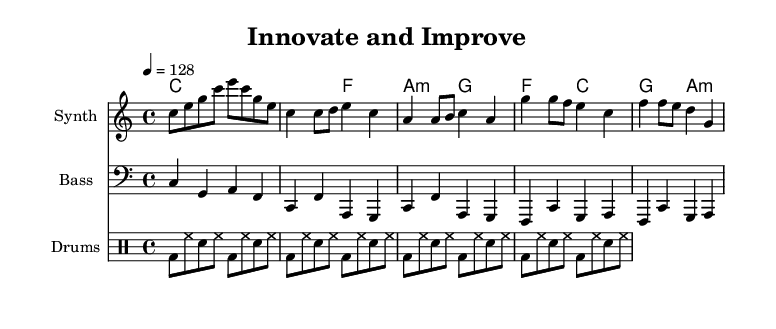What is the key signature of this music? The key signature is C major, which has no sharps or flats.
Answer: C major What is the time signature of this music? The time signature is indicated as 4/4, meaning there are four beats in a measure.
Answer: 4/4 What is the tempo marking for this piece? The tempo marking indicates a speed of quarter note equals 128 beats per minute.
Answer: 128 How many measures are in the chorus section of this piece? By examining the measures in the music, there are 4 measures in the chorus section.
Answer: 4 What is the main theme of the lyrics? The lyrics center around innovation and continuous improvement, emphasizing striving to enhance quality.
Answer: Innovation and continuous improvement What instrument plays the melody in this score? The melody is played by the Synth, as indicated in the staff header.
Answer: Synth Which musical parts repeat in the score? The drum pattern in "drummode" is indicated to repeat four times in the intro.
Answer: Four times 